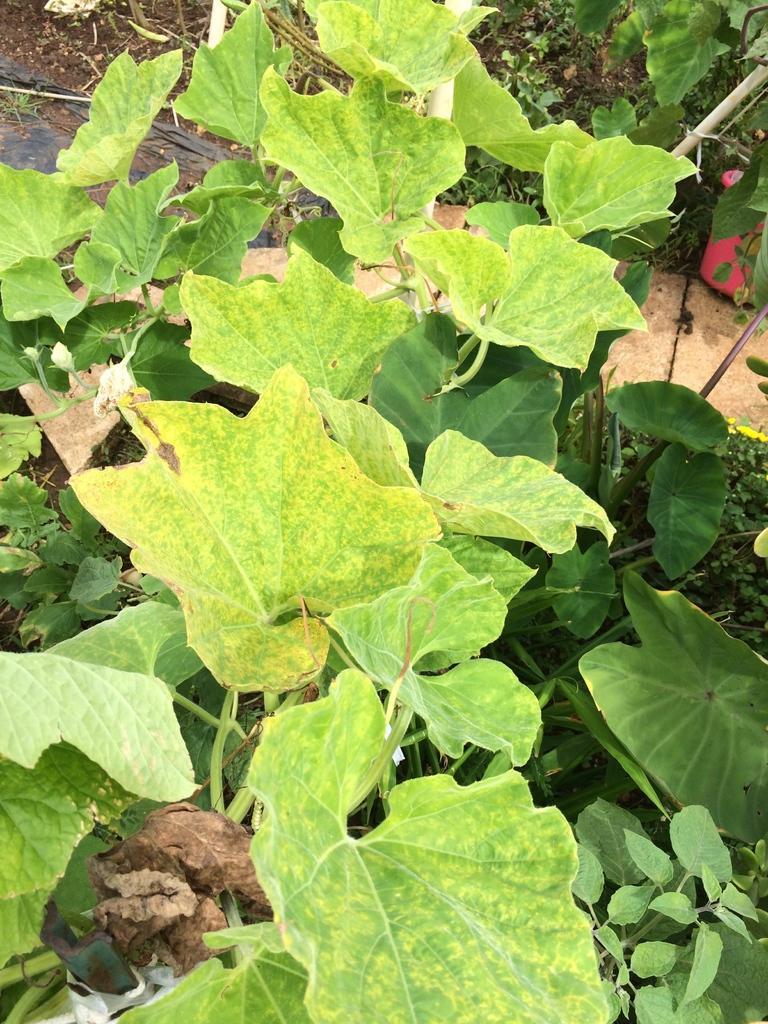Could you give a brief overview of what you see in this image? It is a zoomed in picture of the leaves of the plant. 